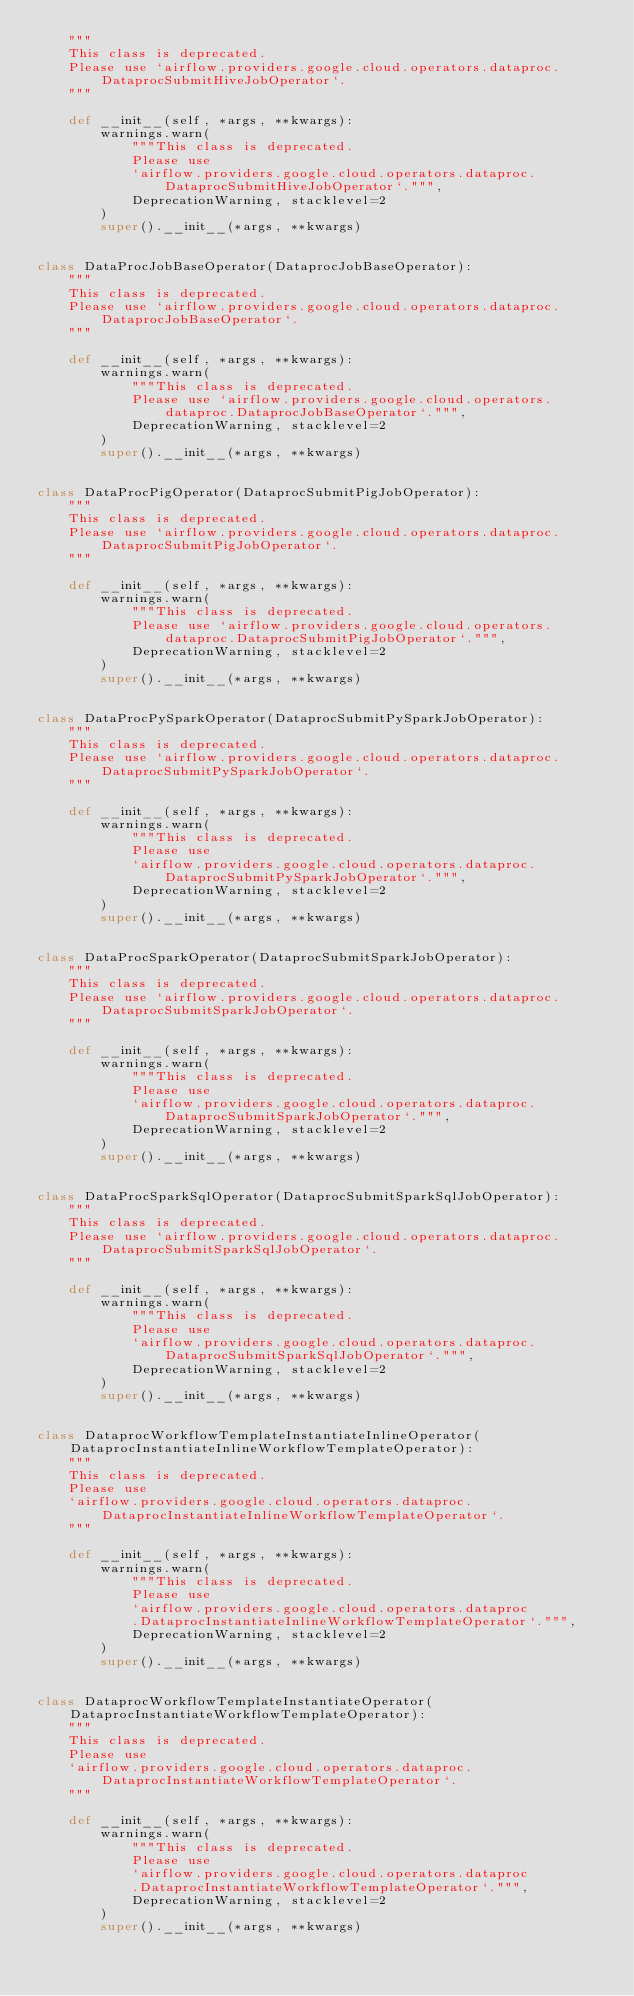Convert code to text. <code><loc_0><loc_0><loc_500><loc_500><_Python_>    """
    This class is deprecated.
    Please use `airflow.providers.google.cloud.operators.dataproc.DataprocSubmitHiveJobOperator`.
    """

    def __init__(self, *args, **kwargs):
        warnings.warn(
            """This class is deprecated.
            Please use
            `airflow.providers.google.cloud.operators.dataproc.DataprocSubmitHiveJobOperator`.""",
            DeprecationWarning, stacklevel=2
        )
        super().__init__(*args, **kwargs)


class DataProcJobBaseOperator(DataprocJobBaseOperator):
    """
    This class is deprecated.
    Please use `airflow.providers.google.cloud.operators.dataproc.DataprocJobBaseOperator`.
    """

    def __init__(self, *args, **kwargs):
        warnings.warn(
            """This class is deprecated.
            Please use `airflow.providers.google.cloud.operators.dataproc.DataprocJobBaseOperator`.""",
            DeprecationWarning, stacklevel=2
        )
        super().__init__(*args, **kwargs)


class DataProcPigOperator(DataprocSubmitPigJobOperator):
    """
    This class is deprecated.
    Please use `airflow.providers.google.cloud.operators.dataproc.DataprocSubmitPigJobOperator`.
    """

    def __init__(self, *args, **kwargs):
        warnings.warn(
            """This class is deprecated.
            Please use `airflow.providers.google.cloud.operators.dataproc.DataprocSubmitPigJobOperator`.""",
            DeprecationWarning, stacklevel=2
        )
        super().__init__(*args, **kwargs)


class DataProcPySparkOperator(DataprocSubmitPySparkJobOperator):
    """
    This class is deprecated.
    Please use `airflow.providers.google.cloud.operators.dataproc.DataprocSubmitPySparkJobOperator`.
    """

    def __init__(self, *args, **kwargs):
        warnings.warn(
            """This class is deprecated.
            Please use
            `airflow.providers.google.cloud.operators.dataproc.DataprocSubmitPySparkJobOperator`.""",
            DeprecationWarning, stacklevel=2
        )
        super().__init__(*args, **kwargs)


class DataProcSparkOperator(DataprocSubmitSparkJobOperator):
    """
    This class is deprecated.
    Please use `airflow.providers.google.cloud.operators.dataproc.DataprocSubmitSparkJobOperator`.
    """

    def __init__(self, *args, **kwargs):
        warnings.warn(
            """This class is deprecated.
            Please use
            `airflow.providers.google.cloud.operators.dataproc.DataprocSubmitSparkJobOperator`.""",
            DeprecationWarning, stacklevel=2
        )
        super().__init__(*args, **kwargs)


class DataProcSparkSqlOperator(DataprocSubmitSparkSqlJobOperator):
    """
    This class is deprecated.
    Please use `airflow.providers.google.cloud.operators.dataproc.DataprocSubmitSparkSqlJobOperator`.
    """

    def __init__(self, *args, **kwargs):
        warnings.warn(
            """This class is deprecated.
            Please use
            `airflow.providers.google.cloud.operators.dataproc.DataprocSubmitSparkSqlJobOperator`.""",
            DeprecationWarning, stacklevel=2
        )
        super().__init__(*args, **kwargs)


class DataprocWorkflowTemplateInstantiateInlineOperator(DataprocInstantiateInlineWorkflowTemplateOperator):
    """
    This class is deprecated.
    Please use
    `airflow.providers.google.cloud.operators.dataproc.DataprocInstantiateInlineWorkflowTemplateOperator`.
    """

    def __init__(self, *args, **kwargs):
        warnings.warn(
            """This class is deprecated.
            Please use
            `airflow.providers.google.cloud.operators.dataproc
            .DataprocInstantiateInlineWorkflowTemplateOperator`.""",
            DeprecationWarning, stacklevel=2
        )
        super().__init__(*args, **kwargs)


class DataprocWorkflowTemplateInstantiateOperator(DataprocInstantiateWorkflowTemplateOperator):
    """
    This class is deprecated.
    Please use
    `airflow.providers.google.cloud.operators.dataproc.DataprocInstantiateWorkflowTemplateOperator`.
    """

    def __init__(self, *args, **kwargs):
        warnings.warn(
            """This class is deprecated.
            Please use
            `airflow.providers.google.cloud.operators.dataproc
            .DataprocInstantiateWorkflowTemplateOperator`.""",
            DeprecationWarning, stacklevel=2
        )
        super().__init__(*args, **kwargs)
</code> 